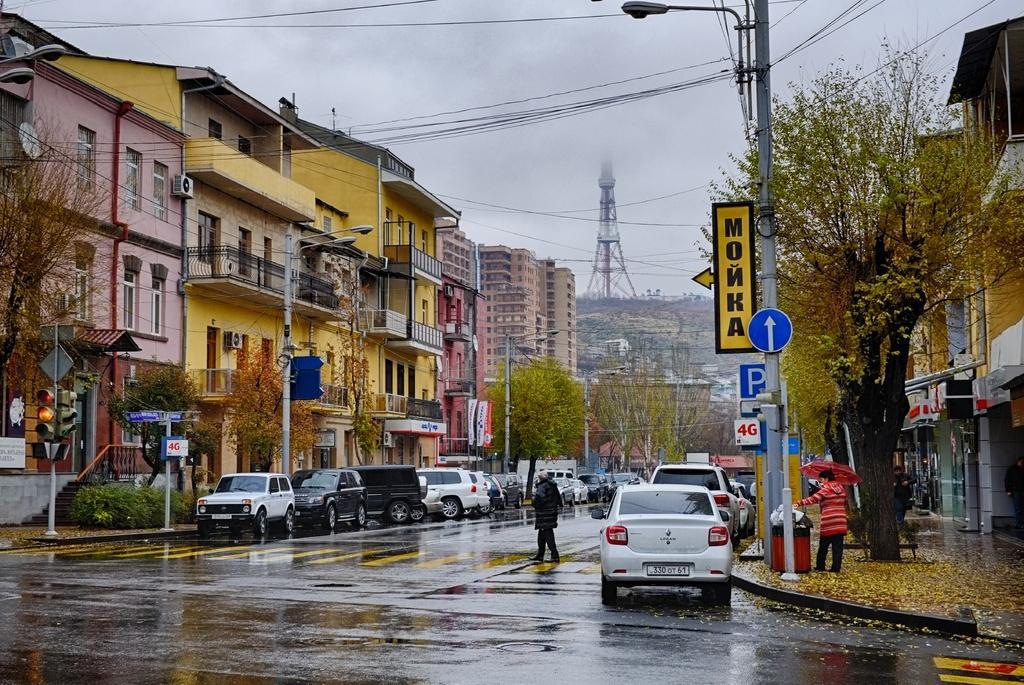In one or two sentences, can you explain what this image depicts? In the image there is a wet road, there are a lot of vehicles parked beside the road and on the left side there are many apartments and buildings and around the road there are some trees and caution boards, in the background there is a tower. 